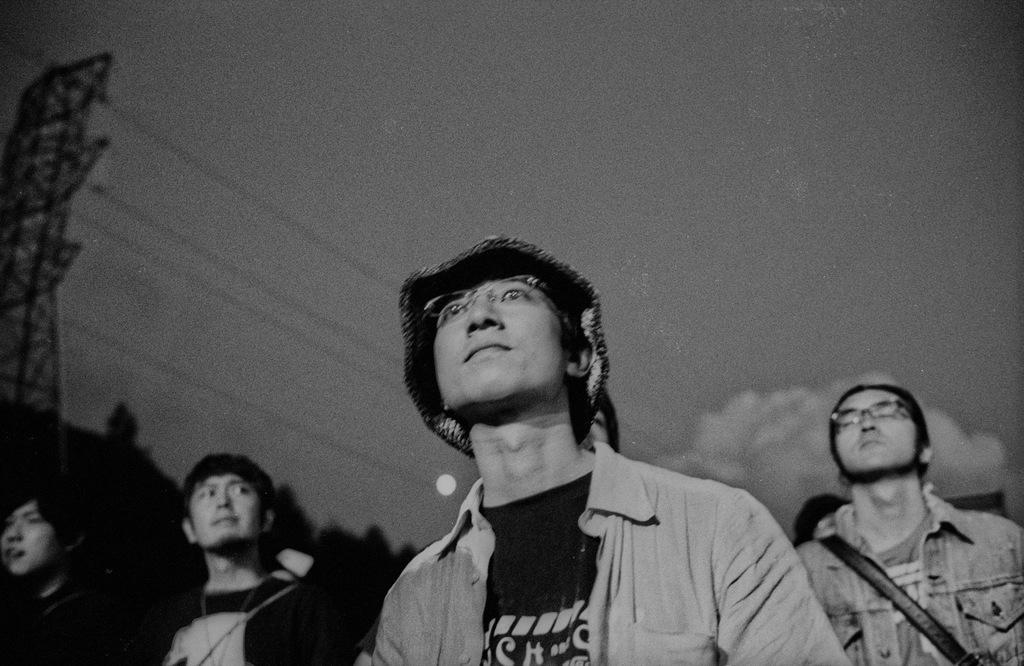What is the color scheme of the image? The image is black and white. What can be seen in the sky in the image? Clouds are present in the sky. What type of structure is in the image? There is a tower in the image. What type of vegetation is present in the image? Trees are present in the image. What else can be seen in the image? Electric cables and men at the bottom of the image are visible. How does the tree participate in the distribution of goods in the image? There is no tree present in the image, and therefore no distribution of goods can be observed. What type of voyage are the men at the bottom of the image embarking on? There is no indication of a voyage in the image; the men are simply standing at the bottom. 